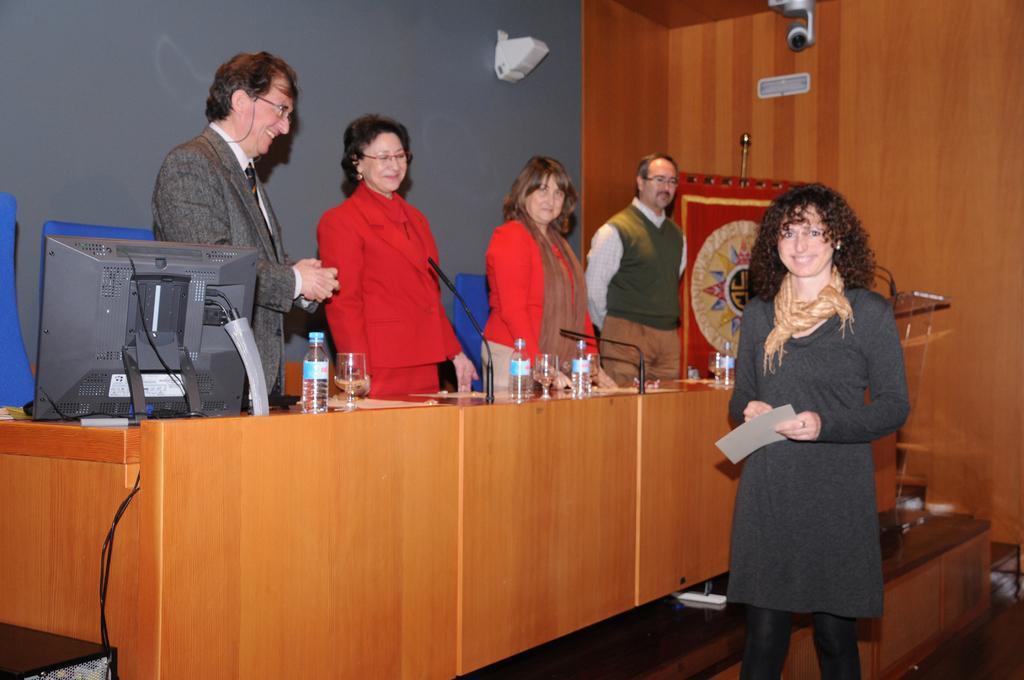Could you give a brief overview of what you see in this image? In this image there is a bench, on the bench there is are mikes, bottles, glasses, system, in front of the bench there is a woman holding a paper, behind the bench there are four persons standing in front of wall, there are blue color chairs visible behind the people, on the right side there is a wooden fence, at the top there is a camera, there is a cable cord visible in the bottom left attached to the bench. 